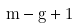Convert formula to latex. <formula><loc_0><loc_0><loc_500><loc_500>m - g + 1</formula> 